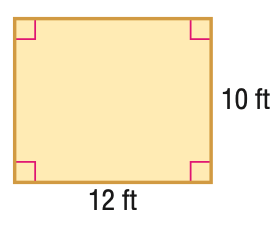Answer the mathemtical geometry problem and directly provide the correct option letter.
Question: Find the perimeter of the figure.
Choices: A: 22 B: 44 C: 60 D: 120 B 